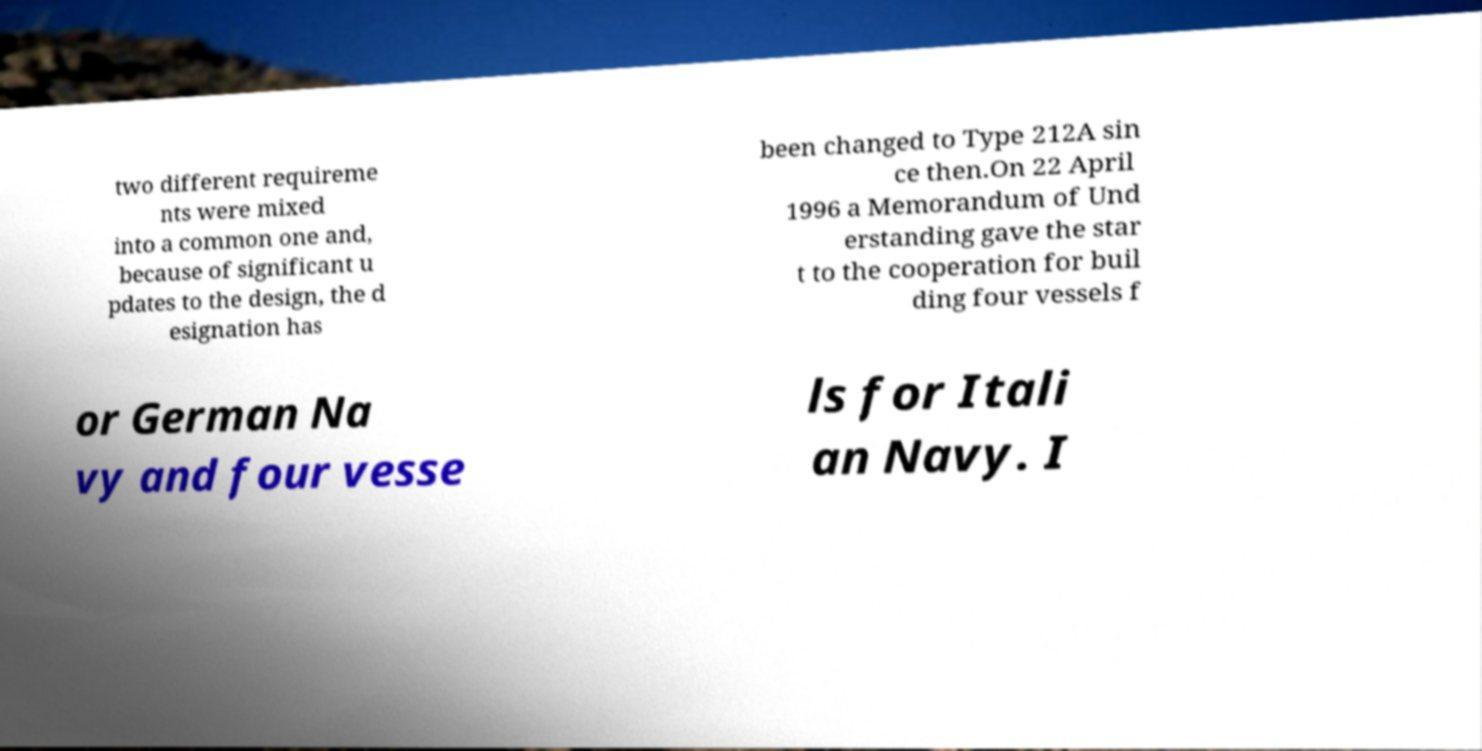Please read and relay the text visible in this image. What does it say? two different requireme nts were mixed into a common one and, because of significant u pdates to the design, the d esignation has been changed to Type 212A sin ce then.On 22 April 1996 a Memorandum of Und erstanding gave the star t to the cooperation for buil ding four vessels f or German Na vy and four vesse ls for Itali an Navy. I 